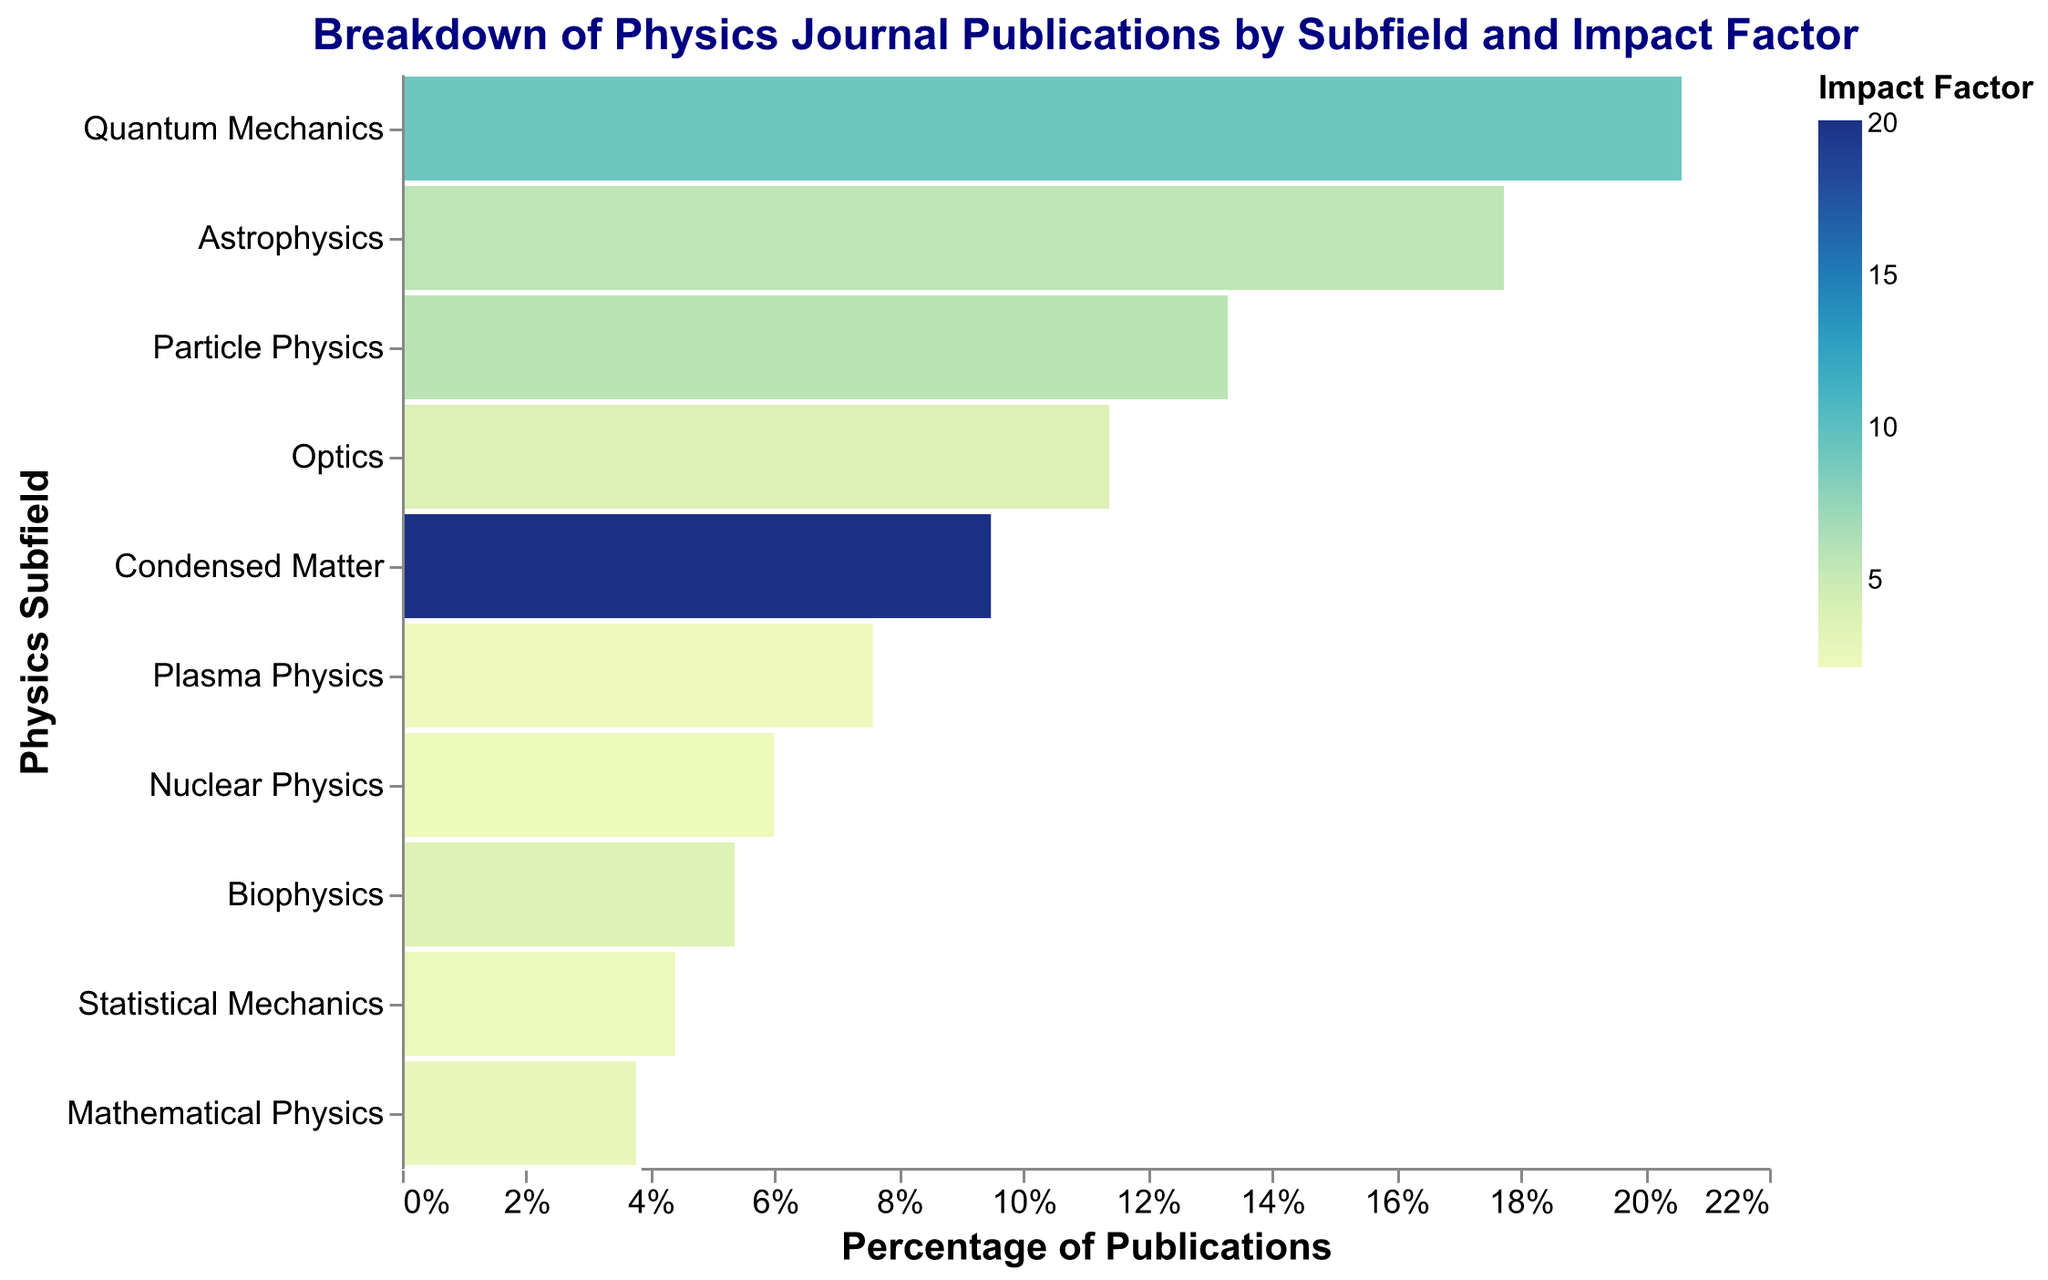What is the title of the figure? The title of the figure is usually placed at the top of the plot and is indicated in larger or bold text. From the description, we know the title is "Breakdown of Physics Journal Publications by Subfield and Impact Factor".
Answer: Breakdown of Physics Journal Publications by Subfield and Impact Factor Which subfield has the highest number of publications? To determine which subfield has the highest number of publications, look for the subfield with the widest section on the x-axis, since it indicates a larger proportion of the total publications. Quantum Mechanics is the subfield with the widest segment.
Answer: Quantum Mechanics What is the color indicating the impact factor of Condensed Matter? Each color in the plot represents a specific impact factor value, and the legend shows the correspondence between the colors and the impact factors. The color of Condensed Matter will be associated with its impact factor, which is 20.113, reflected by a specific shade from the color scale.
Answer: The color represents approximately 20.113 impact factor How does the publication percentage of Quantum Mechanics compare to Astrophysics? To compare the publication percentages, measure the width of the sections corresponding to Quantum Mechanics and Astrophysics on the x-axis. Quantum Mechanics has a wider section than Astrophysics, indicating a higher percentage of total publications.
Answer: Quantum Mechanics has a higher percentage Which subfield has the lowest impact factor, and what is its value? The impact factor is indicated by color. By identifying the lightest or most shaded end and checking the corresponding subfield, we see that Plasma Physics has the lowest impact factor, which is 2.142.
Answer: Plasma Physics, 2.142 What is the total number of publications for the Optics subfield? Hover over or refer to the section of the plot dedicated to Optics; the tooltip or the size of the section can help identify the publication numbers. The number given for Optics is 180.
Answer: 180 How does the impact factor of Particle Physics compare to that of Mathematical Physics? Examine the colors assigned to Particle Physics and Mathematical Physics, and then refer to the legend for the exact values. The impact factor of Particle Physics (5.833) is higher than that of Mathematical Physics (2.686).
Answer: Particle Physics has a higher impact factor Which subfield has the smallest publication count, and what is its value? By observing the sections on the figure, the smallest width will correspond to the lowest publication count, which is for Mathematical Physics with 60 publications.
Answer: Mathematical Physics, 60 What is the publication percentage for Nuclear Physics? For Nuclear Physics, determine the width of the section on the x-axis and relate it to the total publication percentage. Given its narrower section, it contributes a relatively smaller percentage of the total publications.
Answer: It is approximately 7.6% 